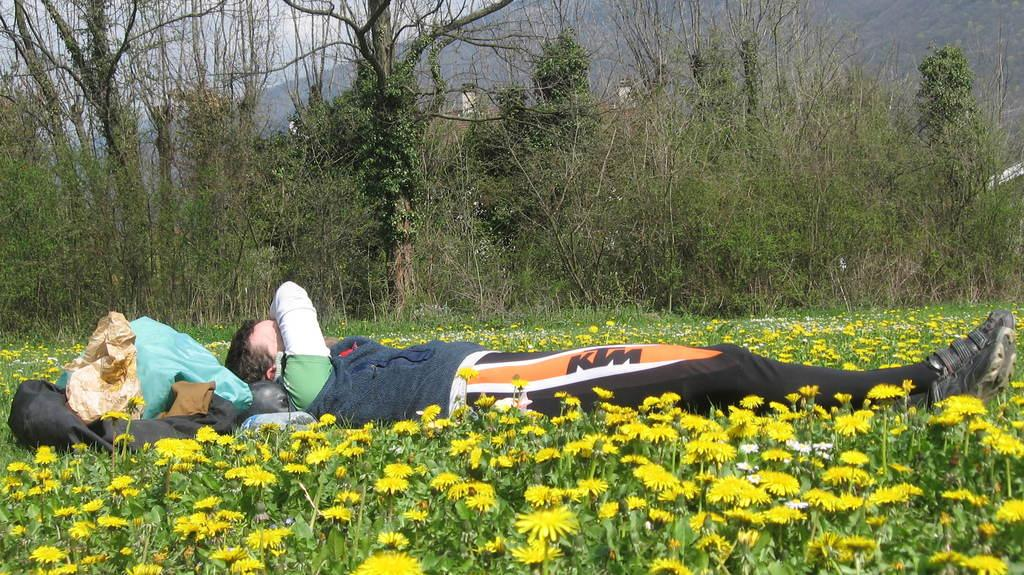What type of vegetation can be seen in the image? There are trees and plants with flowers in the image. What is the man in the image doing? The man is lying down in the image. Where are the clothes located in the image? The clothes are on the left side of the image. What can be seen in the background of the image? There is a hill visible in the background, and the sky is cloudy. What type of brick structure is visible in the image? There is no brick structure present in the image. What government policy is being discussed in the image? There is no discussion of government policy in the image. 